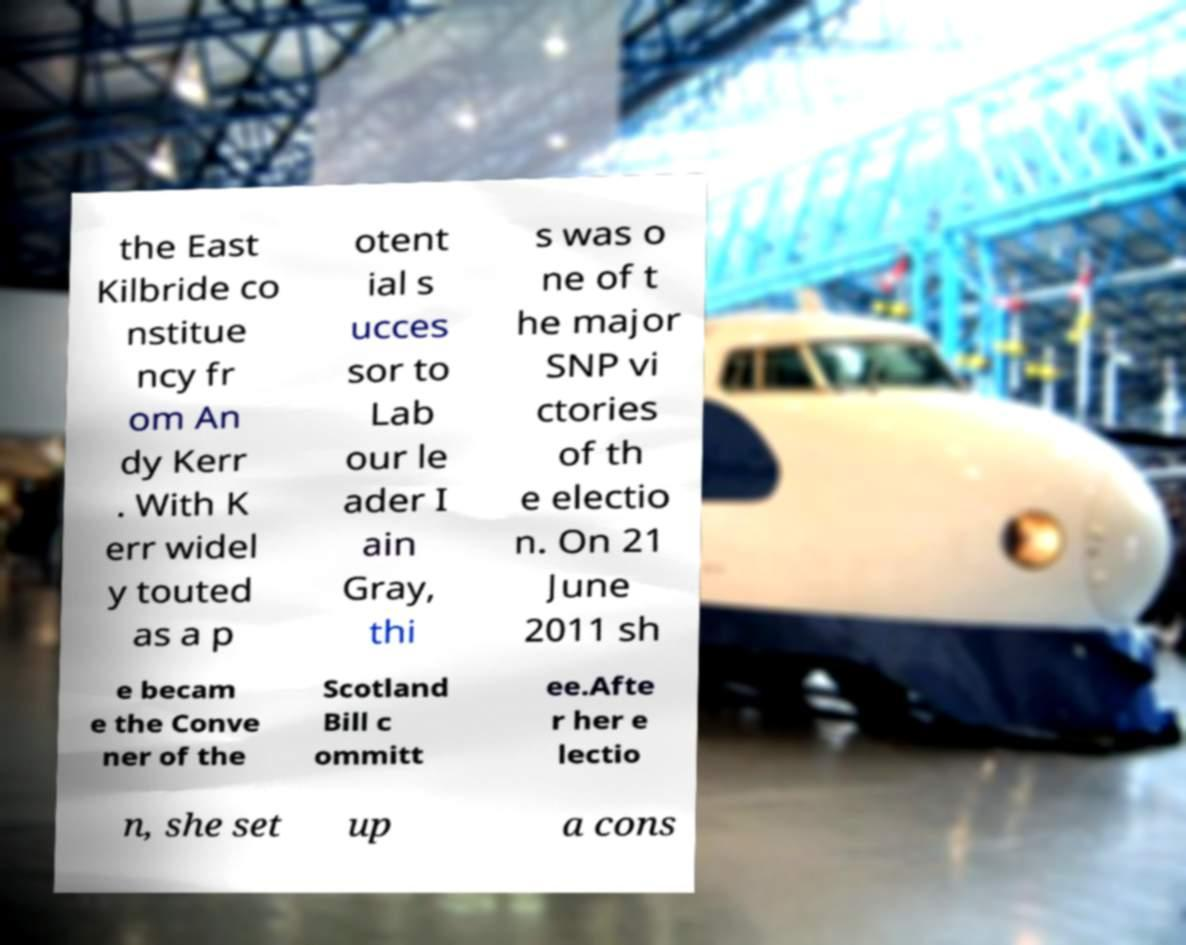Could you extract and type out the text from this image? the East Kilbride co nstitue ncy fr om An dy Kerr . With K err widel y touted as a p otent ial s ucces sor to Lab our le ader I ain Gray, thi s was o ne of t he major SNP vi ctories of th e electio n. On 21 June 2011 sh e becam e the Conve ner of the Scotland Bill c ommitt ee.Afte r her e lectio n, she set up a cons 